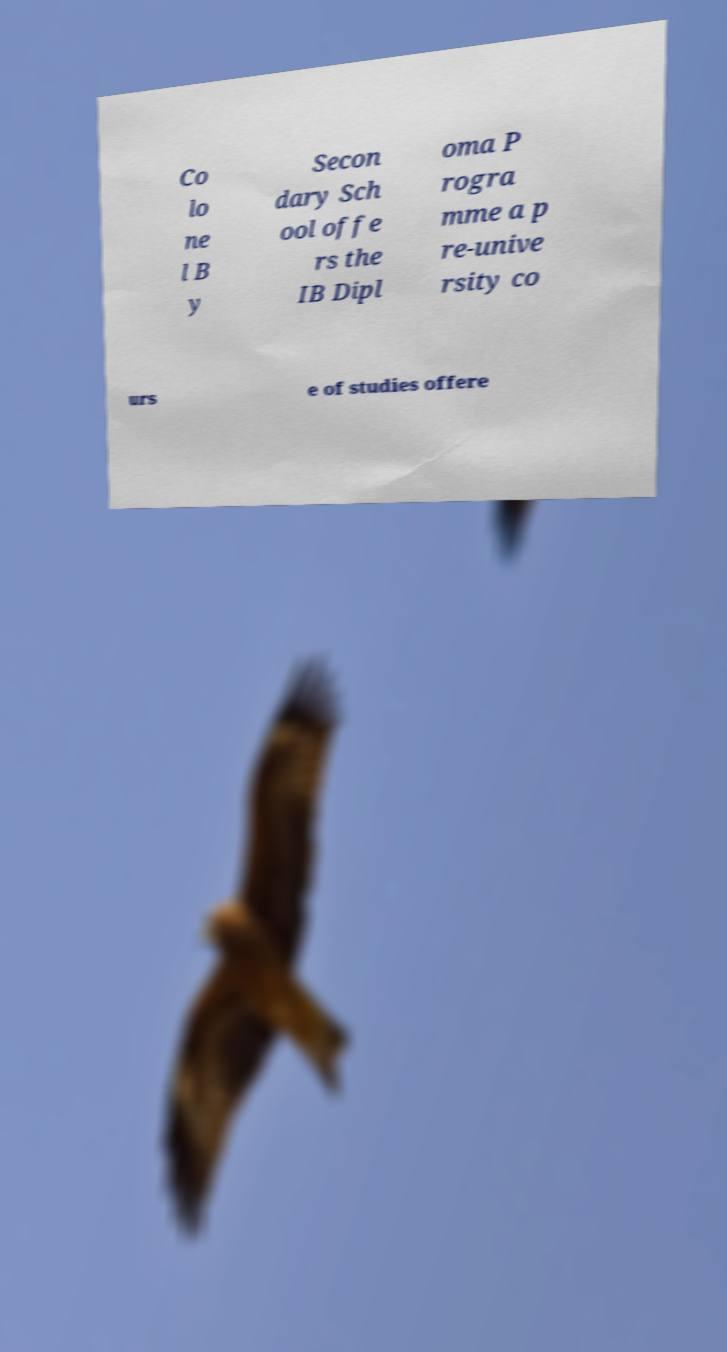Please identify and transcribe the text found in this image. Co lo ne l B y Secon dary Sch ool offe rs the IB Dipl oma P rogra mme a p re-unive rsity co urs e of studies offere 